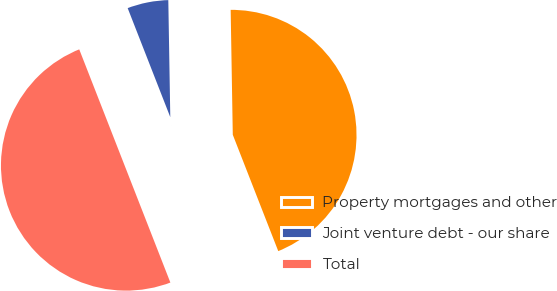<chart> <loc_0><loc_0><loc_500><loc_500><pie_chart><fcel>Property mortgages and other<fcel>Joint venture debt - our share<fcel>Total<nl><fcel>44.34%<fcel>5.66%<fcel>50.0%<nl></chart> 